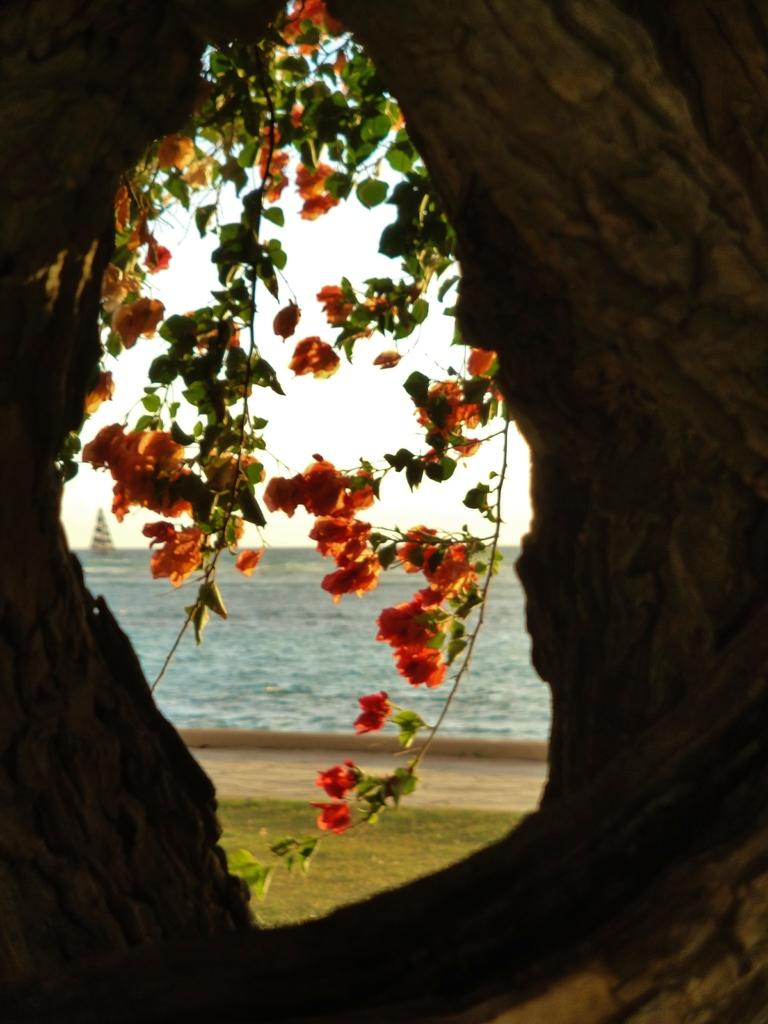What is the main feature of the image? There is a hole in the image. What can be seen through the hole? Stems with leaves and flowers are visible through the hole. What is in the background of the image? There is water and the sky visible in the background of the image. What is on the water? There is a boat on the water. What type of exchange is taking place between the committee and the bat in the image? There is no committee, bat, or exchange present in the image. 